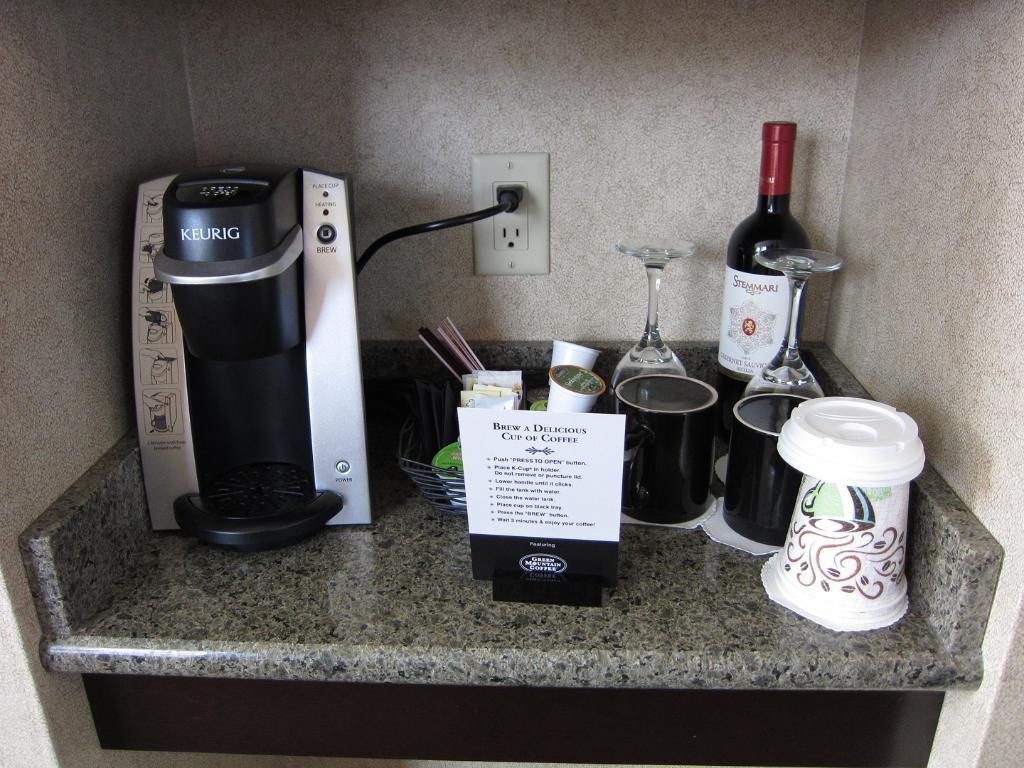<image>
Give a short and clear explanation of the subsequent image. A Keurig sits on a counter with a sign that tells you how to brew a perfect cup of coffee, cups, wine glasses, and a bottle of Stemmari Cabernet Sauvignon. 